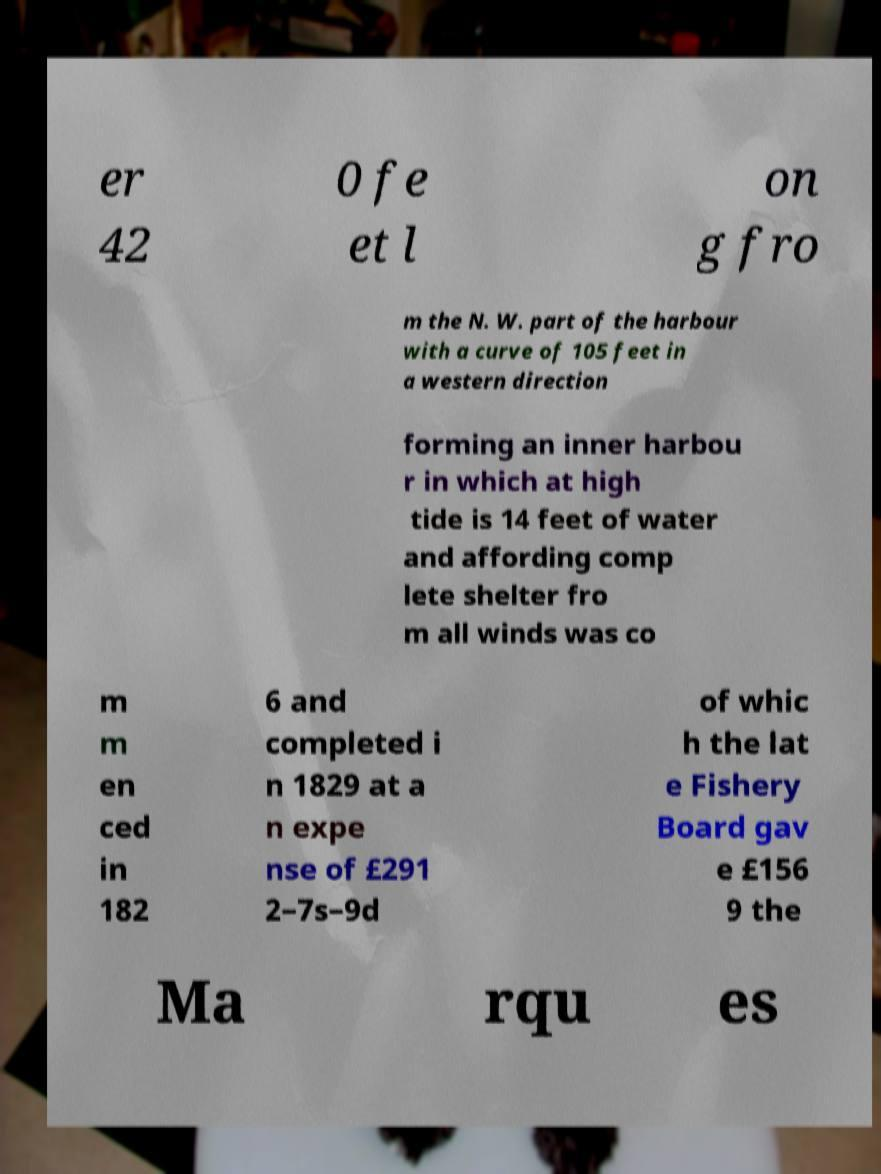Could you extract and type out the text from this image? er 42 0 fe et l on g fro m the N. W. part of the harbour with a curve of 105 feet in a western direction forming an inner harbou r in which at high tide is 14 feet of water and affording comp lete shelter fro m all winds was co m m en ced in 182 6 and completed i n 1829 at a n expe nse of £291 2–7s–9d of whic h the lat e Fishery Board gav e £156 9 the Ma rqu es 